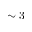Convert formula to latex. <formula><loc_0><loc_0><loc_500><loc_500>\sim 3</formula> 